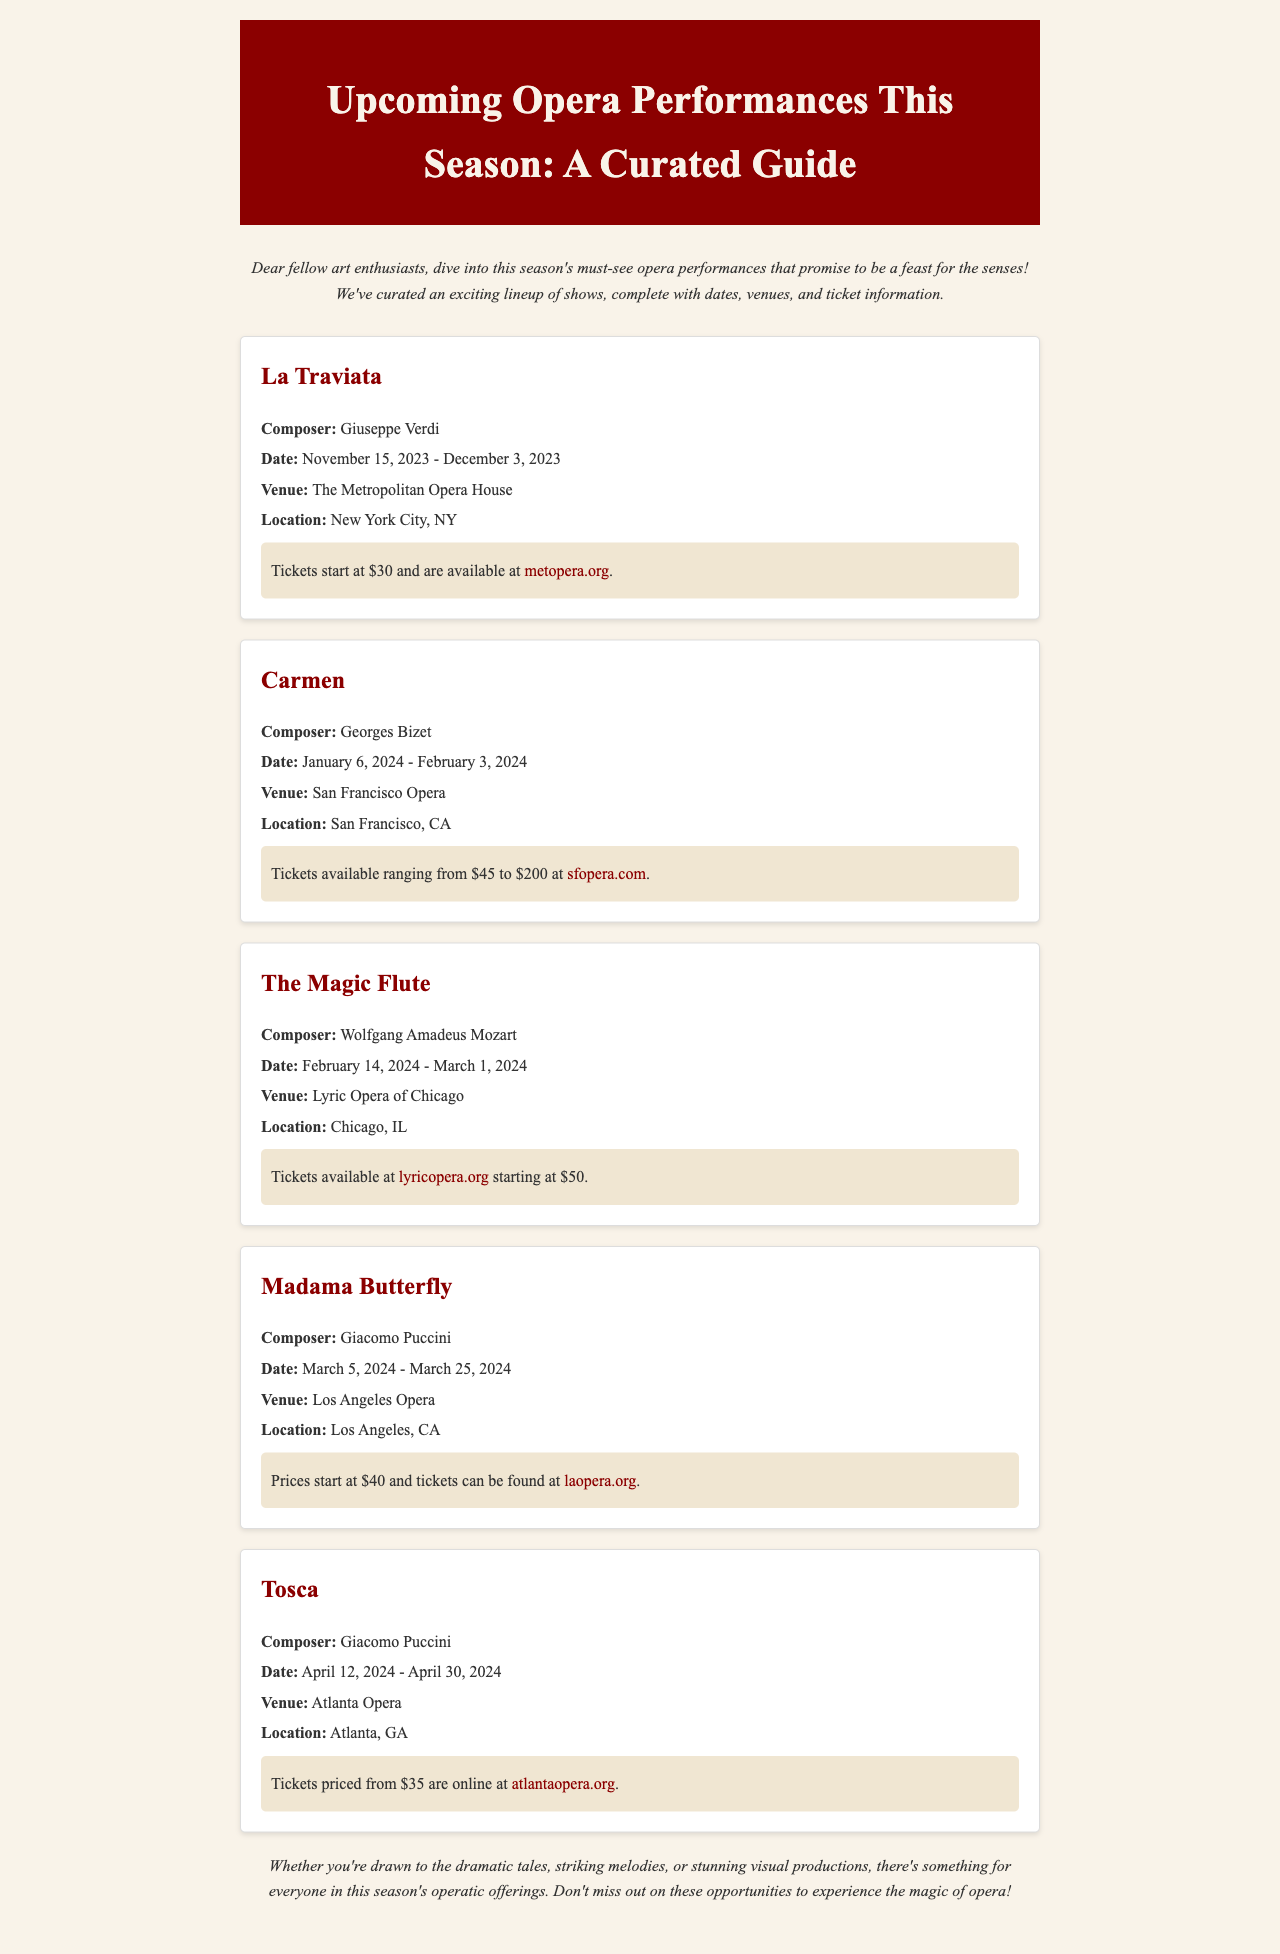what is the first opera listed? The first opera mentioned in the document is "La Traviata."
Answer: La Traviata who is the composer of Carmen? The composer of "Carmen" is Georges Bizet.
Answer: Georges Bizet what are the ticket prices for The Magic Flute? The ticket prices for "The Magic Flute" start at $50.
Answer: $50 when does Madama Butterfly premiere? "Madama Butterfly" premieres on March 5, 2024.
Answer: March 5, 2024 which venue will host Tosca? The venue hosting "Tosca" is Atlanta Opera.
Answer: Atlanta Opera how long is the run for La Traviata? "La Traviata" runs from November 15, 2023, to December 3, 2023.
Answer: November 15, 2023 - December 3, 2023 what city will Carmen be performed in? "Carmen" will be performed in San Francisco.
Answer: San Francisco how many operas are mentioned in the newsletter? The newsletter mentions five operas.
Answer: five what is the tone of the closing paragraph? The closing paragraph expresses enthusiasm for experiencing opera.
Answer: enthusiasm 